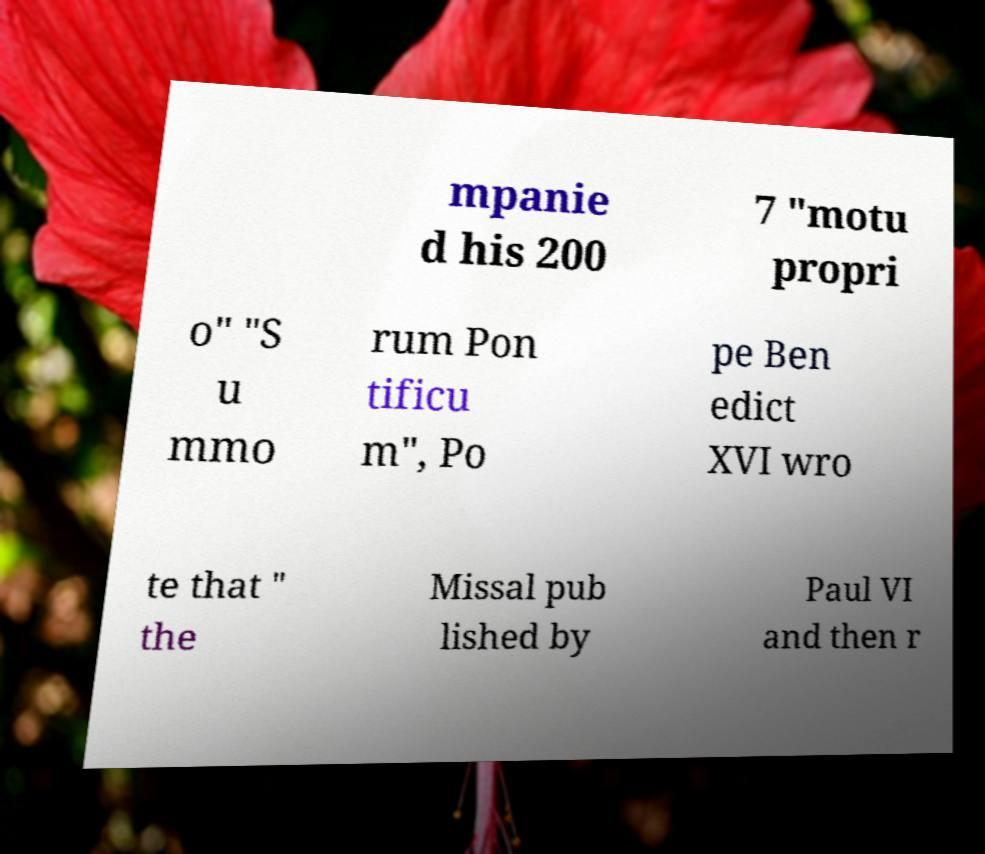There's text embedded in this image that I need extracted. Can you transcribe it verbatim? mpanie d his 200 7 "motu propri o" "S u mmo rum Pon tificu m", Po pe Ben edict XVI wro te that " the Missal pub lished by Paul VI and then r 